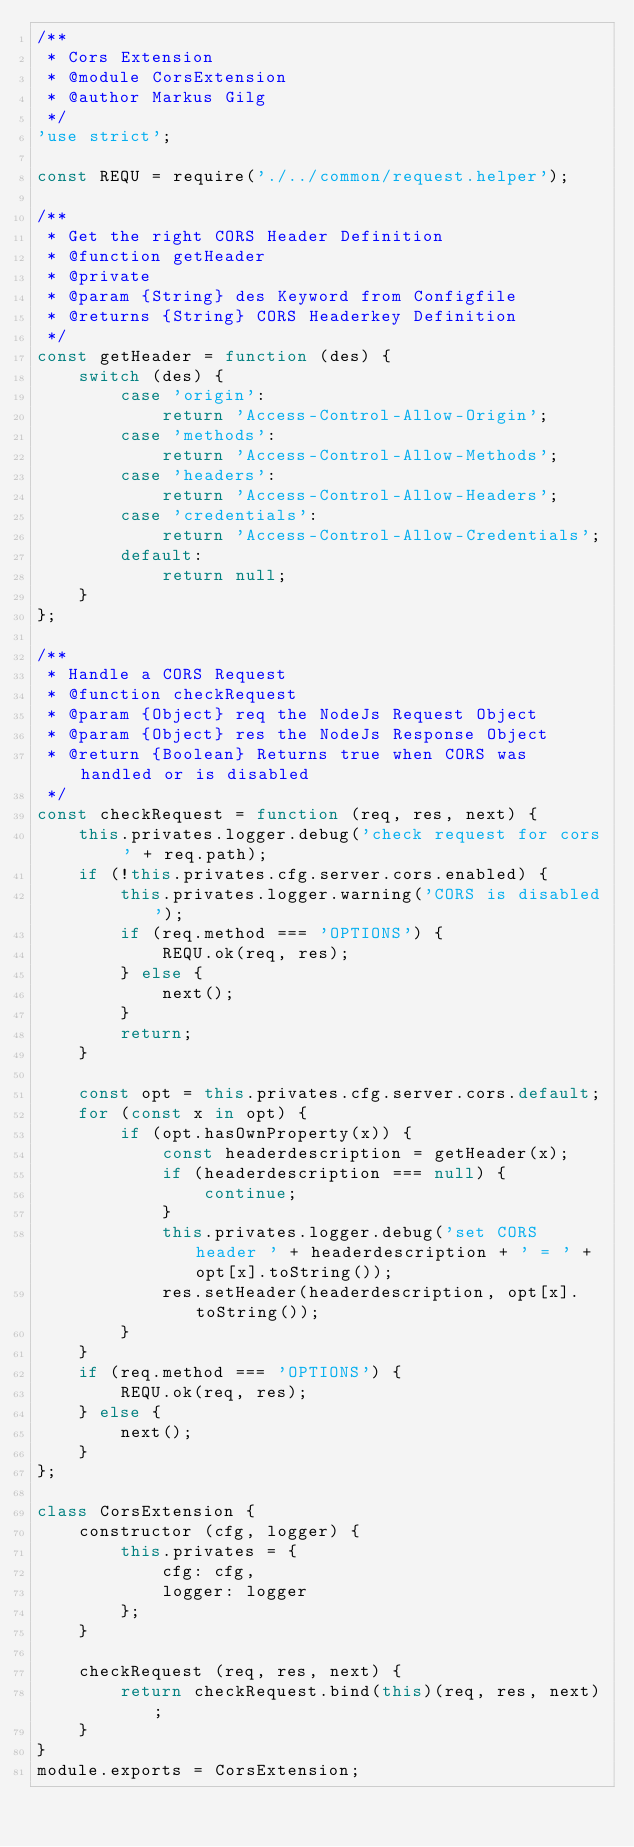Convert code to text. <code><loc_0><loc_0><loc_500><loc_500><_JavaScript_>/**
 * Cors Extension
 * @module CorsExtension
 * @author Markus Gilg
 */
'use strict';

const REQU = require('./../common/request.helper');

/**
 * Get the right CORS Header Definition
 * @function getHeader
 * @private
 * @param {String} des Keyword from Configfile
 * @returns {String} CORS Headerkey Definition
 */
const getHeader = function (des) {
    switch (des) {
        case 'origin':
            return 'Access-Control-Allow-Origin';
        case 'methods':
            return 'Access-Control-Allow-Methods';
        case 'headers':
            return 'Access-Control-Allow-Headers';
        case 'credentials':
            return 'Access-Control-Allow-Credentials';
        default:
            return null;
    }
};

/**
 * Handle a CORS Request
 * @function checkRequest
 * @param {Object} req the NodeJs Request Object
 * @param {Object} res the NodeJs Response Object
 * @return {Boolean} Returns true when CORS was handled or is disabled
 */
const checkRequest = function (req, res, next) {
    this.privates.logger.debug('check request for cors ' + req.path);
    if (!this.privates.cfg.server.cors.enabled) {
        this.privates.logger.warning('CORS is disabled');
        if (req.method === 'OPTIONS') {
            REQU.ok(req, res);
        } else {
            next();
        }
        return;
    }

    const opt = this.privates.cfg.server.cors.default;
    for (const x in opt) {
        if (opt.hasOwnProperty(x)) {
            const headerdescription = getHeader(x);
            if (headerdescription === null) {
                continue;
            }
            this.privates.logger.debug('set CORS header ' + headerdescription + ' = ' + opt[x].toString());
            res.setHeader(headerdescription, opt[x].toString());
        }
    }
    if (req.method === 'OPTIONS') {
        REQU.ok(req, res);
    } else {
        next();
    }
};

class CorsExtension {
    constructor (cfg, logger) {
        this.privates = {
            cfg: cfg,
            logger: logger
        };
    }

    checkRequest (req, res, next) {
        return checkRequest.bind(this)(req, res, next);
    }
}
module.exports = CorsExtension;
</code> 